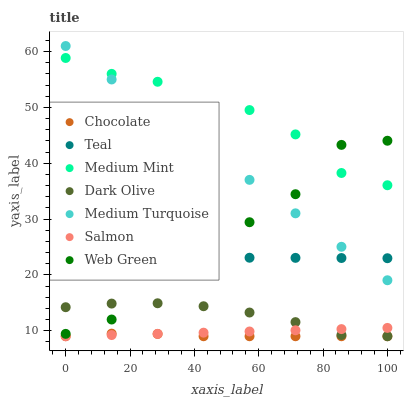Does Chocolate have the minimum area under the curve?
Answer yes or no. Yes. Does Medium Mint have the maximum area under the curve?
Answer yes or no. Yes. Does Teal have the minimum area under the curve?
Answer yes or no. No. Does Teal have the maximum area under the curve?
Answer yes or no. No. Is Salmon the smoothest?
Answer yes or no. Yes. Is Web Green the roughest?
Answer yes or no. Yes. Is Teal the smoothest?
Answer yes or no. No. Is Teal the roughest?
Answer yes or no. No. Does Dark Olive have the lowest value?
Answer yes or no. Yes. Does Teal have the lowest value?
Answer yes or no. No. Does Medium Turquoise have the highest value?
Answer yes or no. Yes. Does Teal have the highest value?
Answer yes or no. No. Is Salmon less than Medium Turquoise?
Answer yes or no. Yes. Is Web Green greater than Salmon?
Answer yes or no. Yes. Does Teal intersect Web Green?
Answer yes or no. Yes. Is Teal less than Web Green?
Answer yes or no. No. Is Teal greater than Web Green?
Answer yes or no. No. Does Salmon intersect Medium Turquoise?
Answer yes or no. No. 